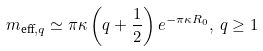Convert formula to latex. <formula><loc_0><loc_0><loc_500><loc_500>m _ { \text {eff} , q } \simeq \pi \kappa \left ( q + \frac { 1 } { 2 } \right ) e ^ { - \pi \kappa R _ { 0 } } , \, q \geq 1</formula> 